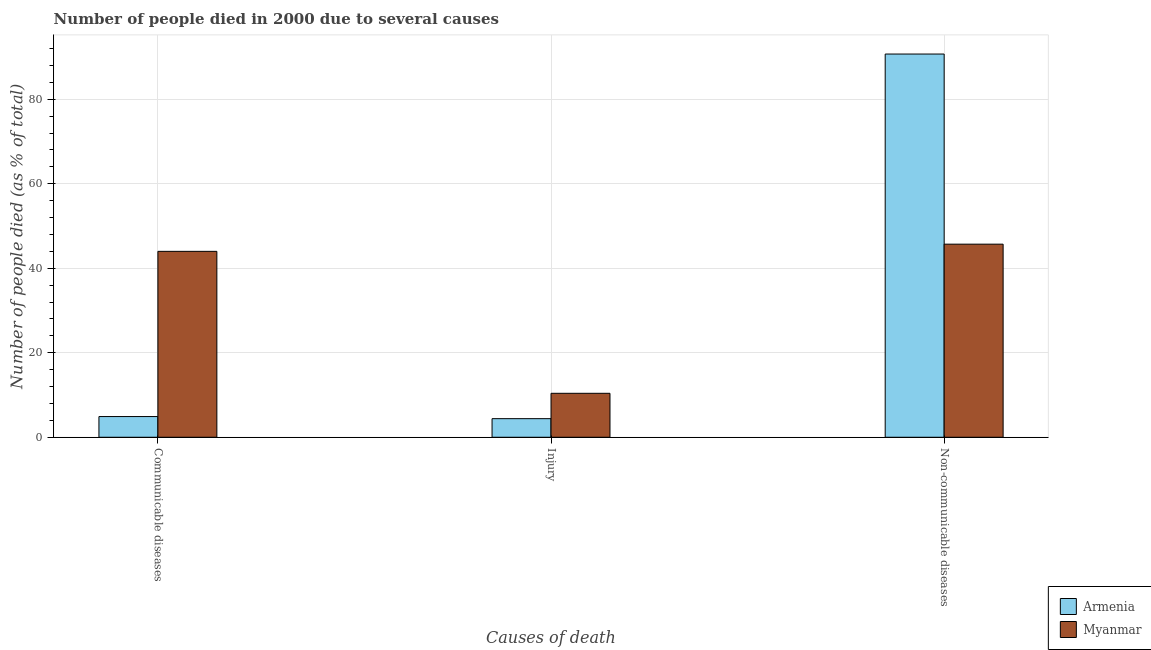How many different coloured bars are there?
Provide a short and direct response. 2. Are the number of bars per tick equal to the number of legend labels?
Offer a very short reply. Yes. How many bars are there on the 1st tick from the right?
Make the answer very short. 2. What is the label of the 3rd group of bars from the left?
Offer a very short reply. Non-communicable diseases. In which country was the number of people who died of communicable diseases maximum?
Your answer should be very brief. Myanmar. In which country was the number of people who died of injury minimum?
Provide a short and direct response. Armenia. What is the total number of people who died of injury in the graph?
Your answer should be very brief. 14.8. What is the difference between the number of people who dies of non-communicable diseases in Armenia and the number of people who died of injury in Myanmar?
Provide a succinct answer. 80.3. What is the average number of people who died of communicable diseases per country?
Offer a terse response. 24.45. What is the difference between the number of people who died of communicable diseases and number of people who dies of non-communicable diseases in Armenia?
Your response must be concise. -85.8. In how many countries, is the number of people who died of communicable diseases greater than 32 %?
Offer a terse response. 1. What is the ratio of the number of people who died of injury in Armenia to that in Myanmar?
Offer a terse response. 0.42. What is the difference between the highest and the lowest number of people who dies of non-communicable diseases?
Your answer should be compact. 45. In how many countries, is the number of people who died of communicable diseases greater than the average number of people who died of communicable diseases taken over all countries?
Your answer should be compact. 1. Is the sum of the number of people who died of injury in Myanmar and Armenia greater than the maximum number of people who died of communicable diseases across all countries?
Your answer should be very brief. No. What does the 2nd bar from the left in Injury represents?
Your answer should be very brief. Myanmar. What does the 1st bar from the right in Communicable diseases represents?
Offer a very short reply. Myanmar. How many bars are there?
Offer a terse response. 6. How many countries are there in the graph?
Your answer should be very brief. 2. What is the difference between two consecutive major ticks on the Y-axis?
Keep it short and to the point. 20. Are the values on the major ticks of Y-axis written in scientific E-notation?
Make the answer very short. No. Where does the legend appear in the graph?
Offer a very short reply. Bottom right. How many legend labels are there?
Provide a succinct answer. 2. What is the title of the graph?
Provide a short and direct response. Number of people died in 2000 due to several causes. Does "Mozambique" appear as one of the legend labels in the graph?
Your answer should be very brief. No. What is the label or title of the X-axis?
Offer a terse response. Causes of death. What is the label or title of the Y-axis?
Your answer should be compact. Number of people died (as % of total). What is the Number of people died (as % of total) in Armenia in Communicable diseases?
Provide a short and direct response. 4.9. What is the Number of people died (as % of total) in Myanmar in Communicable diseases?
Keep it short and to the point. 44. What is the Number of people died (as % of total) of Armenia in Injury?
Offer a terse response. 4.4. What is the Number of people died (as % of total) in Armenia in Non-communicable diseases?
Provide a succinct answer. 90.7. What is the Number of people died (as % of total) of Myanmar in Non-communicable diseases?
Make the answer very short. 45.7. Across all Causes of death, what is the maximum Number of people died (as % of total) of Armenia?
Your answer should be very brief. 90.7. Across all Causes of death, what is the maximum Number of people died (as % of total) in Myanmar?
Your answer should be compact. 45.7. Across all Causes of death, what is the minimum Number of people died (as % of total) of Myanmar?
Keep it short and to the point. 10.4. What is the total Number of people died (as % of total) in Armenia in the graph?
Provide a succinct answer. 100. What is the total Number of people died (as % of total) of Myanmar in the graph?
Offer a terse response. 100.1. What is the difference between the Number of people died (as % of total) in Armenia in Communicable diseases and that in Injury?
Your response must be concise. 0.5. What is the difference between the Number of people died (as % of total) of Myanmar in Communicable diseases and that in Injury?
Your response must be concise. 33.6. What is the difference between the Number of people died (as % of total) in Armenia in Communicable diseases and that in Non-communicable diseases?
Your answer should be compact. -85.8. What is the difference between the Number of people died (as % of total) of Armenia in Injury and that in Non-communicable diseases?
Make the answer very short. -86.3. What is the difference between the Number of people died (as % of total) in Myanmar in Injury and that in Non-communicable diseases?
Provide a short and direct response. -35.3. What is the difference between the Number of people died (as % of total) in Armenia in Communicable diseases and the Number of people died (as % of total) in Myanmar in Non-communicable diseases?
Your answer should be very brief. -40.8. What is the difference between the Number of people died (as % of total) of Armenia in Injury and the Number of people died (as % of total) of Myanmar in Non-communicable diseases?
Offer a very short reply. -41.3. What is the average Number of people died (as % of total) of Armenia per Causes of death?
Keep it short and to the point. 33.33. What is the average Number of people died (as % of total) in Myanmar per Causes of death?
Your answer should be compact. 33.37. What is the difference between the Number of people died (as % of total) of Armenia and Number of people died (as % of total) of Myanmar in Communicable diseases?
Your answer should be very brief. -39.1. What is the difference between the Number of people died (as % of total) of Armenia and Number of people died (as % of total) of Myanmar in Non-communicable diseases?
Give a very brief answer. 45. What is the ratio of the Number of people died (as % of total) of Armenia in Communicable diseases to that in Injury?
Make the answer very short. 1.11. What is the ratio of the Number of people died (as % of total) in Myanmar in Communicable diseases to that in Injury?
Offer a terse response. 4.23. What is the ratio of the Number of people died (as % of total) of Armenia in Communicable diseases to that in Non-communicable diseases?
Ensure brevity in your answer.  0.05. What is the ratio of the Number of people died (as % of total) in Myanmar in Communicable diseases to that in Non-communicable diseases?
Provide a short and direct response. 0.96. What is the ratio of the Number of people died (as % of total) of Armenia in Injury to that in Non-communicable diseases?
Your answer should be compact. 0.05. What is the ratio of the Number of people died (as % of total) in Myanmar in Injury to that in Non-communicable diseases?
Provide a succinct answer. 0.23. What is the difference between the highest and the second highest Number of people died (as % of total) of Armenia?
Provide a succinct answer. 85.8. What is the difference between the highest and the lowest Number of people died (as % of total) in Armenia?
Your answer should be very brief. 86.3. What is the difference between the highest and the lowest Number of people died (as % of total) in Myanmar?
Ensure brevity in your answer.  35.3. 